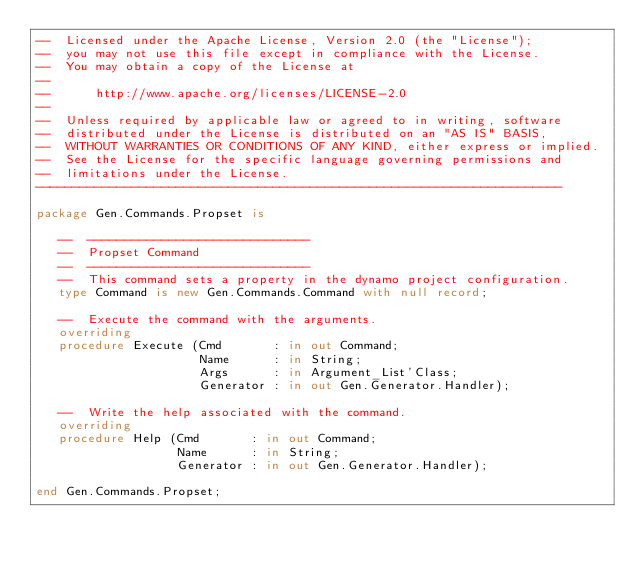Convert code to text. <code><loc_0><loc_0><loc_500><loc_500><_Ada_>--  Licensed under the Apache License, Version 2.0 (the "License");
--  you may not use this file except in compliance with the License.
--  You may obtain a copy of the License at
--
--      http://www.apache.org/licenses/LICENSE-2.0
--
--  Unless required by applicable law or agreed to in writing, software
--  distributed under the License is distributed on an "AS IS" BASIS,
--  WITHOUT WARRANTIES OR CONDITIONS OF ANY KIND, either express or implied.
--  See the License for the specific language governing permissions and
--  limitations under the License.
-----------------------------------------------------------------------

package Gen.Commands.Propset is

   --  ------------------------------
   --  Propset Command
   --  ------------------------------
   --  This command sets a property in the dynamo project configuration.
   type Command is new Gen.Commands.Command with null record;

   --  Execute the command with the arguments.
   overriding
   procedure Execute (Cmd       : in out Command;
                      Name      : in String;
                      Args      : in Argument_List'Class;
                      Generator : in out Gen.Generator.Handler);

   --  Write the help associated with the command.
   overriding
   procedure Help (Cmd       : in out Command;
                   Name      : in String;
                   Generator : in out Gen.Generator.Handler);

end Gen.Commands.Propset;
</code> 